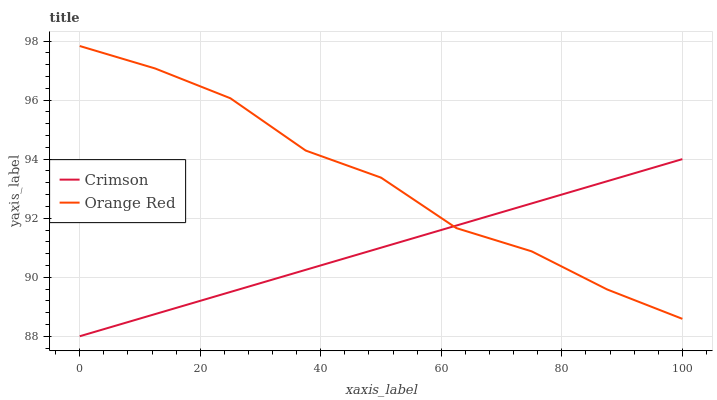Does Crimson have the minimum area under the curve?
Answer yes or no. Yes. Does Orange Red have the maximum area under the curve?
Answer yes or no. Yes. Does Orange Red have the minimum area under the curve?
Answer yes or no. No. Is Crimson the smoothest?
Answer yes or no. Yes. Is Orange Red the roughest?
Answer yes or no. Yes. Is Orange Red the smoothest?
Answer yes or no. No. Does Crimson have the lowest value?
Answer yes or no. Yes. Does Orange Red have the lowest value?
Answer yes or no. No. Does Orange Red have the highest value?
Answer yes or no. Yes. Does Crimson intersect Orange Red?
Answer yes or no. Yes. Is Crimson less than Orange Red?
Answer yes or no. No. Is Crimson greater than Orange Red?
Answer yes or no. No. 